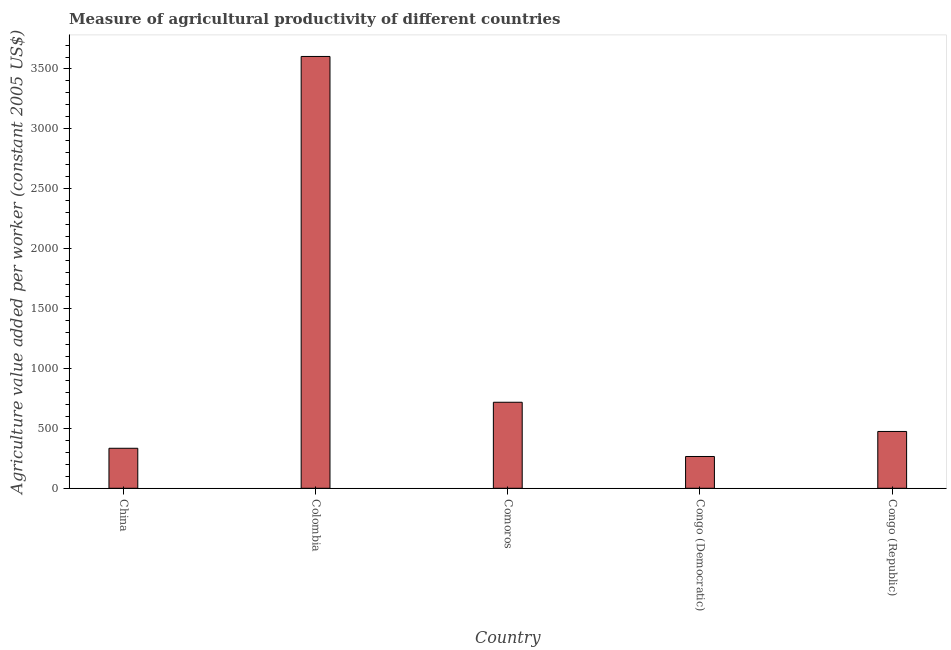What is the title of the graph?
Ensure brevity in your answer.  Measure of agricultural productivity of different countries. What is the label or title of the X-axis?
Give a very brief answer. Country. What is the label or title of the Y-axis?
Your answer should be compact. Agriculture value added per worker (constant 2005 US$). What is the agriculture value added per worker in China?
Ensure brevity in your answer.  333.91. Across all countries, what is the maximum agriculture value added per worker?
Provide a succinct answer. 3604.59. Across all countries, what is the minimum agriculture value added per worker?
Offer a terse response. 265.3. In which country was the agriculture value added per worker maximum?
Your answer should be very brief. Colombia. In which country was the agriculture value added per worker minimum?
Provide a short and direct response. Congo (Democratic). What is the sum of the agriculture value added per worker?
Make the answer very short. 5396.22. What is the difference between the agriculture value added per worker in Comoros and Congo (Republic)?
Keep it short and to the point. 243.82. What is the average agriculture value added per worker per country?
Ensure brevity in your answer.  1079.24. What is the median agriculture value added per worker?
Your response must be concise. 474.3. In how many countries, is the agriculture value added per worker greater than 2600 US$?
Provide a succinct answer. 1. What is the ratio of the agriculture value added per worker in China to that in Comoros?
Ensure brevity in your answer.  0.47. What is the difference between the highest and the second highest agriculture value added per worker?
Keep it short and to the point. 2886.47. What is the difference between the highest and the lowest agriculture value added per worker?
Ensure brevity in your answer.  3339.29. How many bars are there?
Provide a short and direct response. 5. Are all the bars in the graph horizontal?
Your response must be concise. No. How many countries are there in the graph?
Your response must be concise. 5. What is the difference between two consecutive major ticks on the Y-axis?
Provide a succinct answer. 500. What is the Agriculture value added per worker (constant 2005 US$) of China?
Keep it short and to the point. 333.91. What is the Agriculture value added per worker (constant 2005 US$) of Colombia?
Offer a terse response. 3604.59. What is the Agriculture value added per worker (constant 2005 US$) in Comoros?
Make the answer very short. 718.12. What is the Agriculture value added per worker (constant 2005 US$) in Congo (Democratic)?
Make the answer very short. 265.3. What is the Agriculture value added per worker (constant 2005 US$) of Congo (Republic)?
Provide a succinct answer. 474.3. What is the difference between the Agriculture value added per worker (constant 2005 US$) in China and Colombia?
Ensure brevity in your answer.  -3270.68. What is the difference between the Agriculture value added per worker (constant 2005 US$) in China and Comoros?
Your answer should be compact. -384.21. What is the difference between the Agriculture value added per worker (constant 2005 US$) in China and Congo (Democratic)?
Keep it short and to the point. 68.61. What is the difference between the Agriculture value added per worker (constant 2005 US$) in China and Congo (Republic)?
Your answer should be compact. -140.39. What is the difference between the Agriculture value added per worker (constant 2005 US$) in Colombia and Comoros?
Offer a very short reply. 2886.47. What is the difference between the Agriculture value added per worker (constant 2005 US$) in Colombia and Congo (Democratic)?
Ensure brevity in your answer.  3339.29. What is the difference between the Agriculture value added per worker (constant 2005 US$) in Colombia and Congo (Republic)?
Make the answer very short. 3130.29. What is the difference between the Agriculture value added per worker (constant 2005 US$) in Comoros and Congo (Democratic)?
Ensure brevity in your answer.  452.82. What is the difference between the Agriculture value added per worker (constant 2005 US$) in Comoros and Congo (Republic)?
Provide a short and direct response. 243.82. What is the difference between the Agriculture value added per worker (constant 2005 US$) in Congo (Democratic) and Congo (Republic)?
Your answer should be compact. -209.01. What is the ratio of the Agriculture value added per worker (constant 2005 US$) in China to that in Colombia?
Ensure brevity in your answer.  0.09. What is the ratio of the Agriculture value added per worker (constant 2005 US$) in China to that in Comoros?
Provide a succinct answer. 0.47. What is the ratio of the Agriculture value added per worker (constant 2005 US$) in China to that in Congo (Democratic)?
Provide a succinct answer. 1.26. What is the ratio of the Agriculture value added per worker (constant 2005 US$) in China to that in Congo (Republic)?
Provide a succinct answer. 0.7. What is the ratio of the Agriculture value added per worker (constant 2005 US$) in Colombia to that in Comoros?
Make the answer very short. 5.02. What is the ratio of the Agriculture value added per worker (constant 2005 US$) in Colombia to that in Congo (Democratic)?
Make the answer very short. 13.59. What is the ratio of the Agriculture value added per worker (constant 2005 US$) in Colombia to that in Congo (Republic)?
Offer a very short reply. 7.6. What is the ratio of the Agriculture value added per worker (constant 2005 US$) in Comoros to that in Congo (Democratic)?
Give a very brief answer. 2.71. What is the ratio of the Agriculture value added per worker (constant 2005 US$) in Comoros to that in Congo (Republic)?
Keep it short and to the point. 1.51. What is the ratio of the Agriculture value added per worker (constant 2005 US$) in Congo (Democratic) to that in Congo (Republic)?
Your response must be concise. 0.56. 